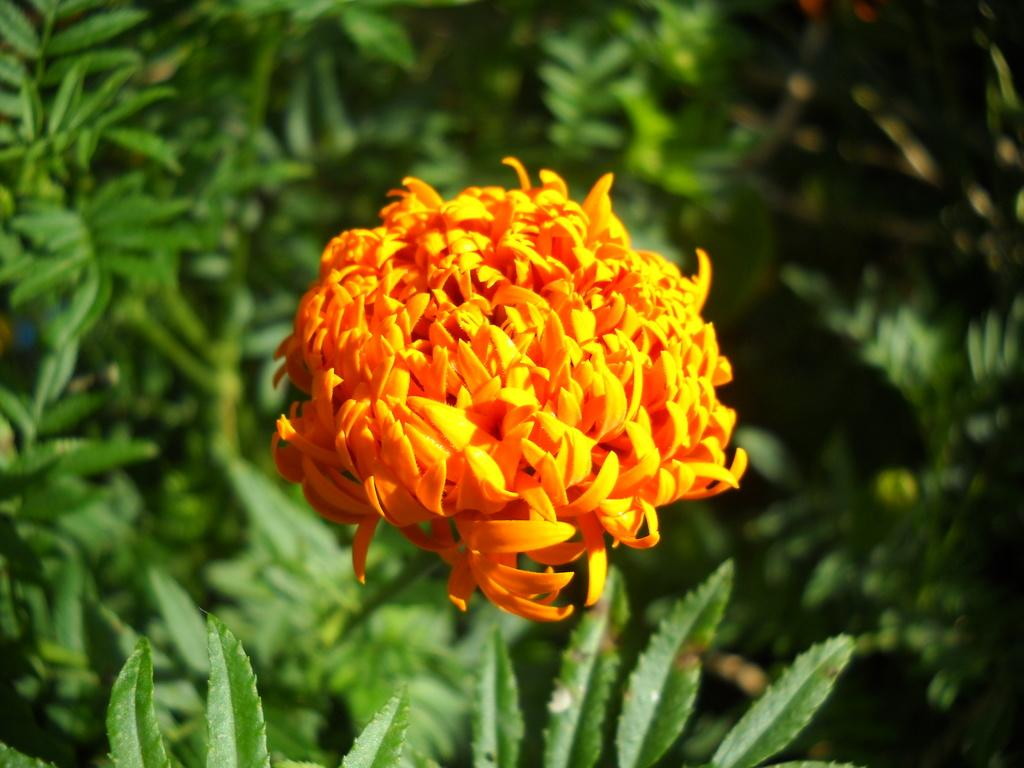What type of plant is featured in the image? There is a plant with a flower in the image. Can you describe the plants in the background of the image? The plants in the background have leaves. Where is the faucet located in the image? There is no faucet present in the image. What type of wood can be seen in the image? There is no wood visible in the image. 